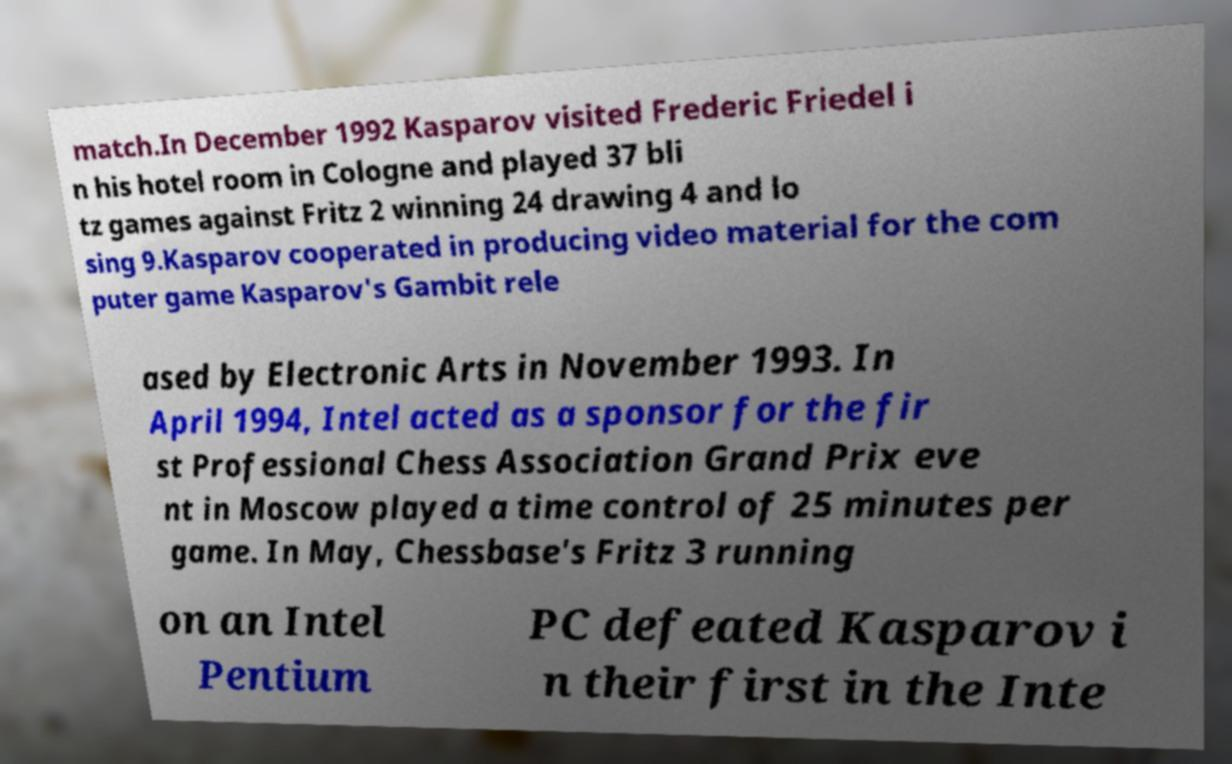What messages or text are displayed in this image? I need them in a readable, typed format. match.In December 1992 Kasparov visited Frederic Friedel i n his hotel room in Cologne and played 37 bli tz games against Fritz 2 winning 24 drawing 4 and lo sing 9.Kasparov cooperated in producing video material for the com puter game Kasparov's Gambit rele ased by Electronic Arts in November 1993. In April 1994, Intel acted as a sponsor for the fir st Professional Chess Association Grand Prix eve nt in Moscow played a time control of 25 minutes per game. In May, Chessbase's Fritz 3 running on an Intel Pentium PC defeated Kasparov i n their first in the Inte 